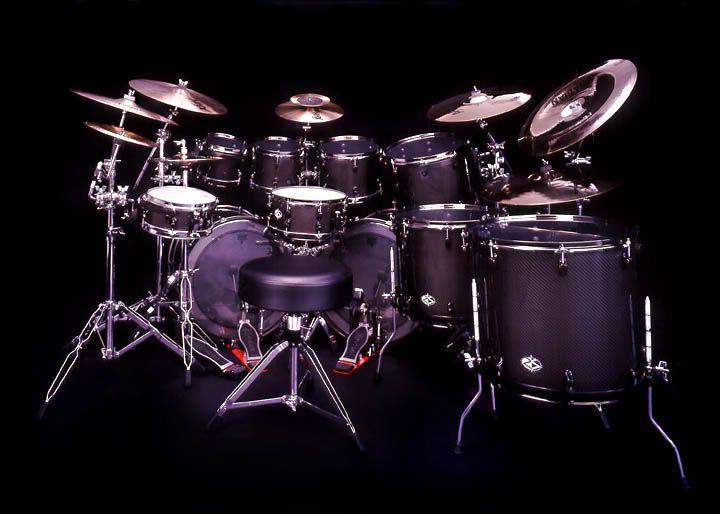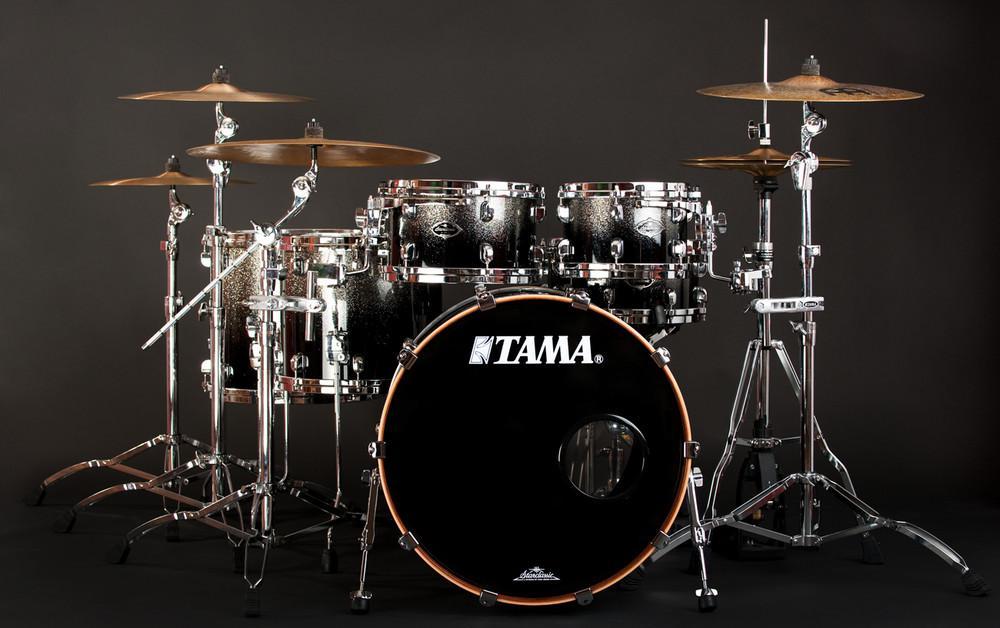The first image is the image on the left, the second image is the image on the right. For the images displayed, is the sentence "The right image contains a drum kit that is predominately red." factually correct? Answer yes or no. No. The first image is the image on the left, the second image is the image on the right. Examine the images to the left and right. Is the description "Two drum kits in different sizes are shown, both with red drum facings and at least one forward-facing black drum." accurate? Answer yes or no. No. 